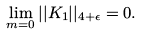<formula> <loc_0><loc_0><loc_500><loc_500>\lim _ { m = 0 } | | K _ { 1 } | | _ { 4 + \epsilon } = 0 .</formula> 